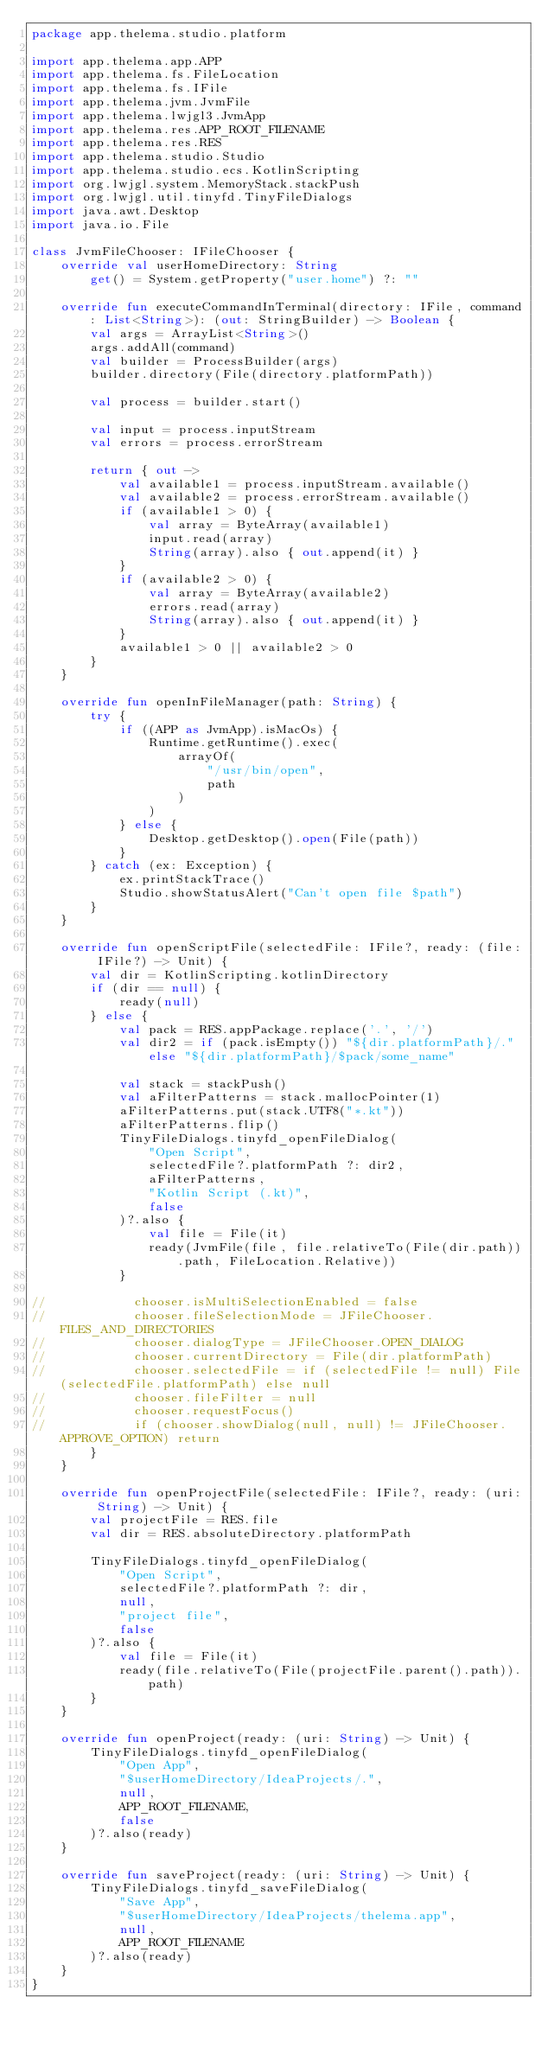<code> <loc_0><loc_0><loc_500><loc_500><_Kotlin_>package app.thelema.studio.platform

import app.thelema.app.APP
import app.thelema.fs.FileLocation
import app.thelema.fs.IFile
import app.thelema.jvm.JvmFile
import app.thelema.lwjgl3.JvmApp
import app.thelema.res.APP_ROOT_FILENAME
import app.thelema.res.RES
import app.thelema.studio.Studio
import app.thelema.studio.ecs.KotlinScripting
import org.lwjgl.system.MemoryStack.stackPush
import org.lwjgl.util.tinyfd.TinyFileDialogs
import java.awt.Desktop
import java.io.File

class JvmFileChooser: IFileChooser {
    override val userHomeDirectory: String
        get() = System.getProperty("user.home") ?: ""

    override fun executeCommandInTerminal(directory: IFile, command: List<String>): (out: StringBuilder) -> Boolean {
        val args = ArrayList<String>()
        args.addAll(command)
        val builder = ProcessBuilder(args)
        builder.directory(File(directory.platformPath))

        val process = builder.start()

        val input = process.inputStream
        val errors = process.errorStream

        return { out ->
            val available1 = process.inputStream.available()
            val available2 = process.errorStream.available()
            if (available1 > 0) {
                val array = ByteArray(available1)
                input.read(array)
                String(array).also { out.append(it) }
            }
            if (available2 > 0) {
                val array = ByteArray(available2)
                errors.read(array)
                String(array).also { out.append(it) }
            }
            available1 > 0 || available2 > 0
        }
    }

    override fun openInFileManager(path: String) {
        try {
            if ((APP as JvmApp).isMacOs) {
                Runtime.getRuntime().exec(
                    arrayOf(
                        "/usr/bin/open",
                        path
                    )
                )
            } else {
                Desktop.getDesktop().open(File(path))
            }
        } catch (ex: Exception) {
            ex.printStackTrace()
            Studio.showStatusAlert("Can't open file $path")
        }
    }

    override fun openScriptFile(selectedFile: IFile?, ready: (file: IFile?) -> Unit) {
        val dir = KotlinScripting.kotlinDirectory
        if (dir == null) {
            ready(null)
        } else {
            val pack = RES.appPackage.replace('.', '/')
            val dir2 = if (pack.isEmpty()) "${dir.platformPath}/." else "${dir.platformPath}/$pack/some_name"

            val stack = stackPush()
            val aFilterPatterns = stack.mallocPointer(1)
            aFilterPatterns.put(stack.UTF8("*.kt"))
            aFilterPatterns.flip()
            TinyFileDialogs.tinyfd_openFileDialog(
                "Open Script",
                selectedFile?.platformPath ?: dir2,
                aFilterPatterns,
                "Kotlin Script (.kt)",
                false
            )?.also {
                val file = File(it)
                ready(JvmFile(file, file.relativeTo(File(dir.path)).path, FileLocation.Relative))
            }

//            chooser.isMultiSelectionEnabled = false
//            chooser.fileSelectionMode = JFileChooser.FILES_AND_DIRECTORIES
//            chooser.dialogType = JFileChooser.OPEN_DIALOG
//            chooser.currentDirectory = File(dir.platformPath)
//            chooser.selectedFile = if (selectedFile != null) File(selectedFile.platformPath) else null
//            chooser.fileFilter = null
//            chooser.requestFocus()
//            if (chooser.showDialog(null, null) != JFileChooser.APPROVE_OPTION) return
        }
    }

    override fun openProjectFile(selectedFile: IFile?, ready: (uri: String) -> Unit) {
        val projectFile = RES.file
        val dir = RES.absoluteDirectory.platformPath

        TinyFileDialogs.tinyfd_openFileDialog(
            "Open Script",
            selectedFile?.platformPath ?: dir,
            null,
            "project file",
            false
        )?.also {
            val file = File(it)
            ready(file.relativeTo(File(projectFile.parent().path)).path)
        }
    }

    override fun openProject(ready: (uri: String) -> Unit) {
        TinyFileDialogs.tinyfd_openFileDialog(
            "Open App",
            "$userHomeDirectory/IdeaProjects/.",
            null,
            APP_ROOT_FILENAME,
            false
        )?.also(ready)
    }

    override fun saveProject(ready: (uri: String) -> Unit) {
        TinyFileDialogs.tinyfd_saveFileDialog(
            "Save App",
            "$userHomeDirectory/IdeaProjects/thelema.app",
            null,
            APP_ROOT_FILENAME
        )?.also(ready)
    }
}
</code> 